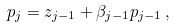<formula> <loc_0><loc_0><loc_500><loc_500>p _ { j } = z _ { j - 1 } + \beta _ { j - 1 } p _ { j - 1 } \, ,</formula> 